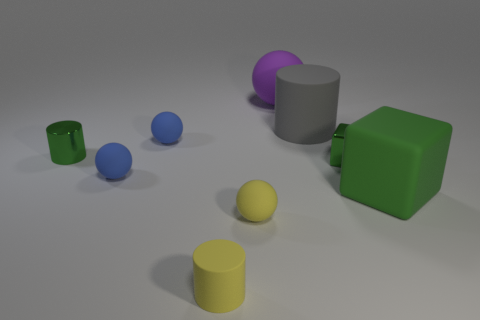Add 1 small green cylinders. How many objects exist? 10 Subtract all tiny yellow matte balls. How many balls are left? 3 Add 2 green metal cylinders. How many green metal cylinders exist? 3 Subtract all purple balls. How many balls are left? 3 Subtract 1 blue spheres. How many objects are left? 8 Subtract all cylinders. How many objects are left? 6 Subtract 1 cylinders. How many cylinders are left? 2 Subtract all cyan cylinders. Subtract all brown balls. How many cylinders are left? 3 Subtract all cyan balls. How many red cubes are left? 0 Subtract all blue matte balls. Subtract all rubber cylinders. How many objects are left? 5 